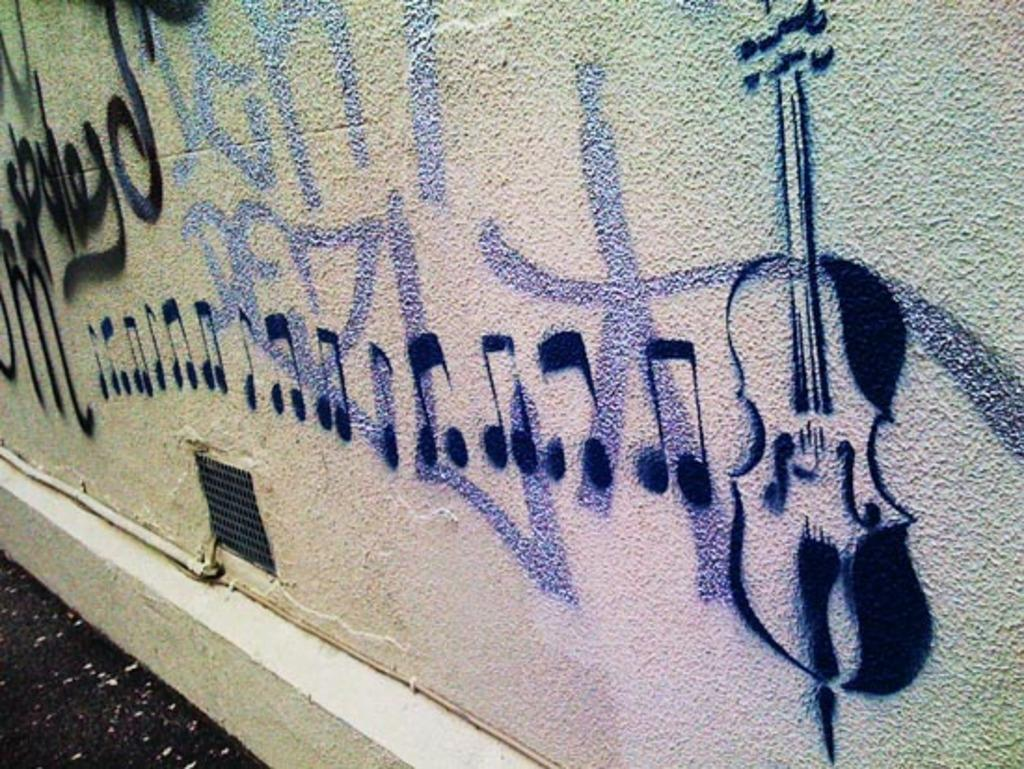What type of object can be seen in the image? There is a pipe in the image. What other object is present in the image? There is a mesh in the image. What is the background of the image? There is a wall in the image. What is depicted on the wall? The wall has a painting of a violin. What additional details can be seen in the painting? The painting includes musical symbols. What type of cord is used to hang the cherry in the image? There is no cord or cherry present in the image. 